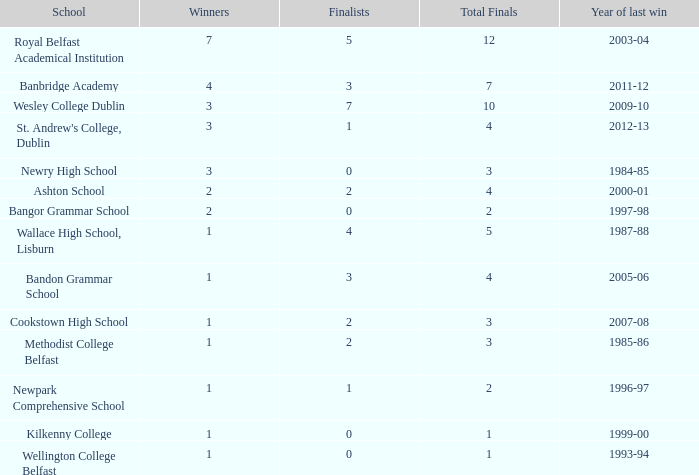In what year was the total finals at 10? 2009-10. 